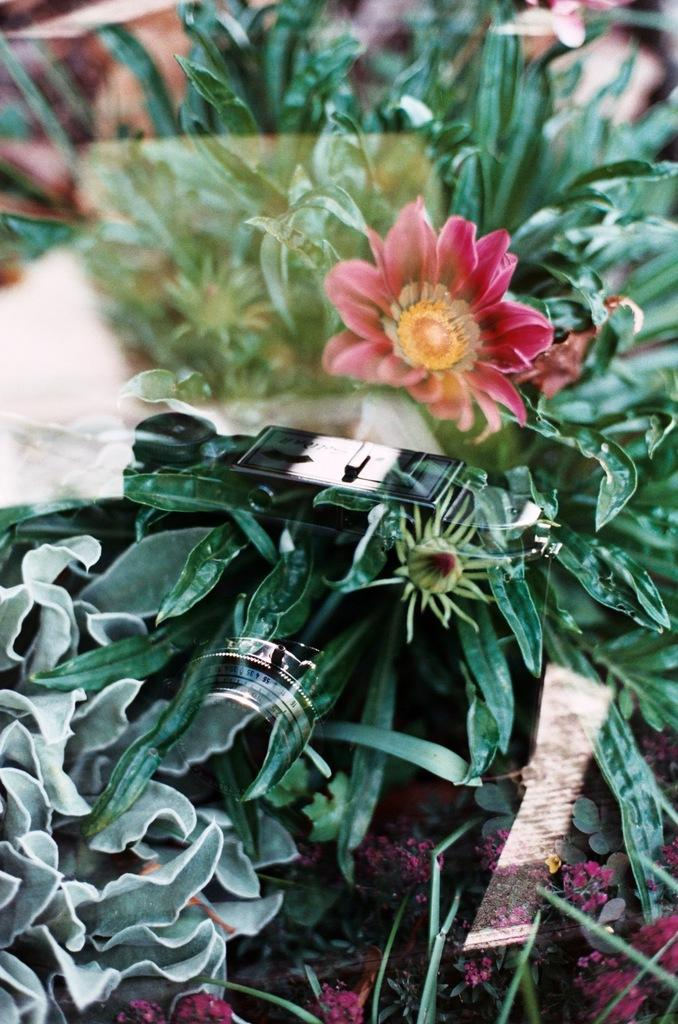What type of plants can be seen in the image? There are flower plants in the image. Can you see any vegetables being polished in the image? There are no vegetables or polishing activities present in the image; it only features flower plants. 